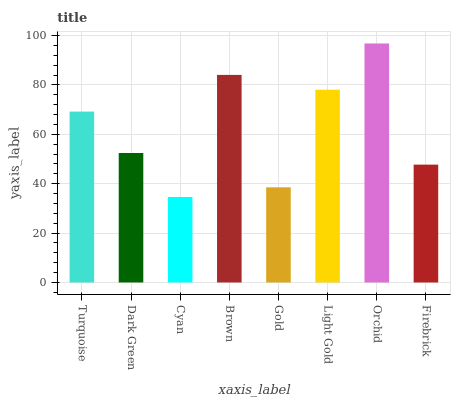Is Cyan the minimum?
Answer yes or no. Yes. Is Orchid the maximum?
Answer yes or no. Yes. Is Dark Green the minimum?
Answer yes or no. No. Is Dark Green the maximum?
Answer yes or no. No. Is Turquoise greater than Dark Green?
Answer yes or no. Yes. Is Dark Green less than Turquoise?
Answer yes or no. Yes. Is Dark Green greater than Turquoise?
Answer yes or no. No. Is Turquoise less than Dark Green?
Answer yes or no. No. Is Turquoise the high median?
Answer yes or no. Yes. Is Dark Green the low median?
Answer yes or no. Yes. Is Brown the high median?
Answer yes or no. No. Is Gold the low median?
Answer yes or no. No. 